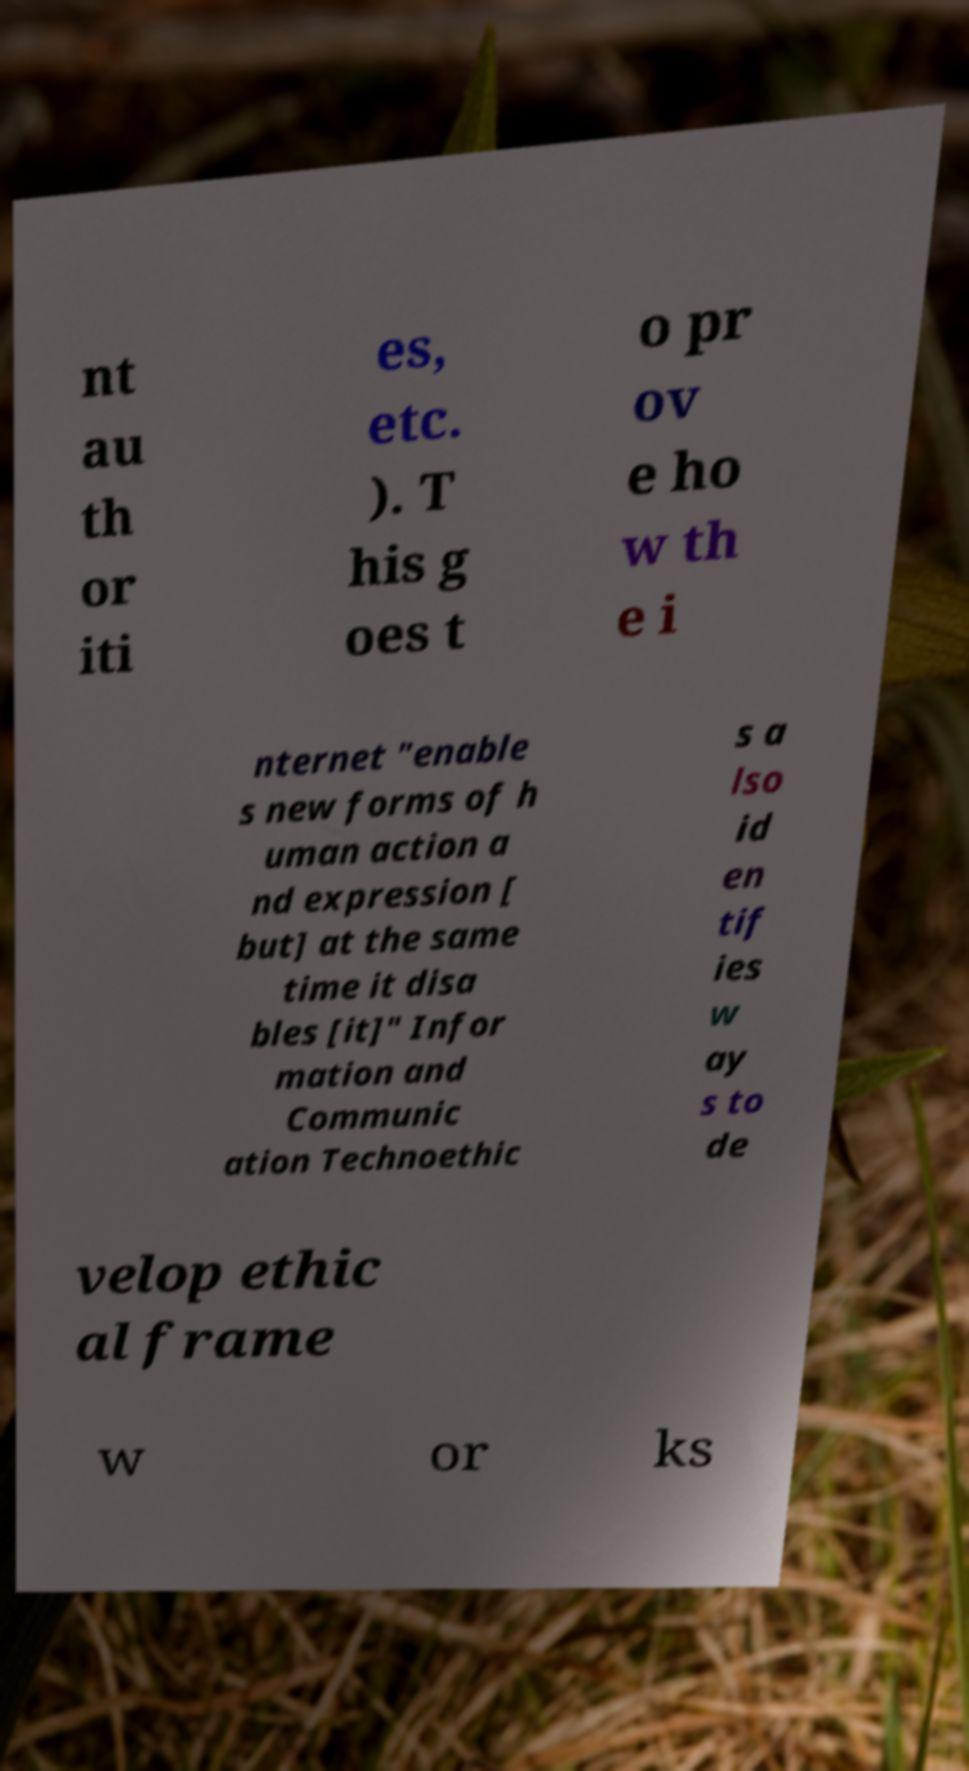For documentation purposes, I need the text within this image transcribed. Could you provide that? nt au th or iti es, etc. ). T his g oes t o pr ov e ho w th e i nternet "enable s new forms of h uman action a nd expression [ but] at the same time it disa bles [it]" Infor mation and Communic ation Technoethic s a lso id en tif ies w ay s to de velop ethic al frame w or ks 